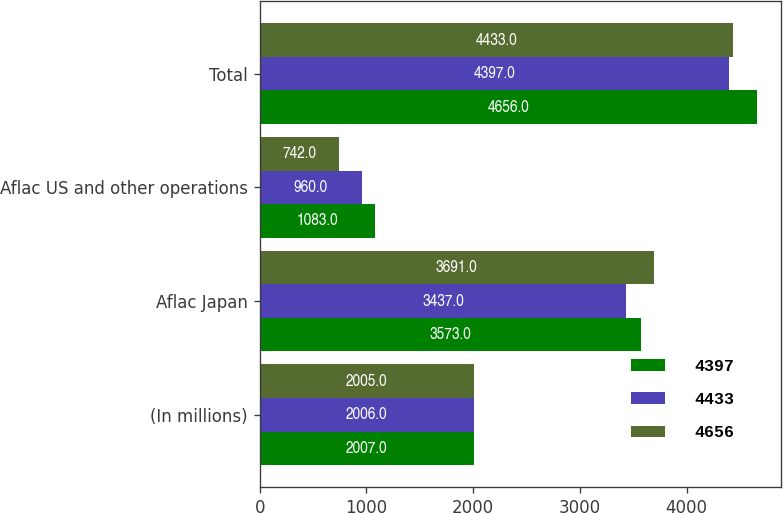Convert chart. <chart><loc_0><loc_0><loc_500><loc_500><stacked_bar_chart><ecel><fcel>(In millions)<fcel>Aflac Japan<fcel>Aflac US and other operations<fcel>Total<nl><fcel>4397<fcel>2007<fcel>3573<fcel>1083<fcel>4656<nl><fcel>4433<fcel>2006<fcel>3437<fcel>960<fcel>4397<nl><fcel>4656<fcel>2005<fcel>3691<fcel>742<fcel>4433<nl></chart> 